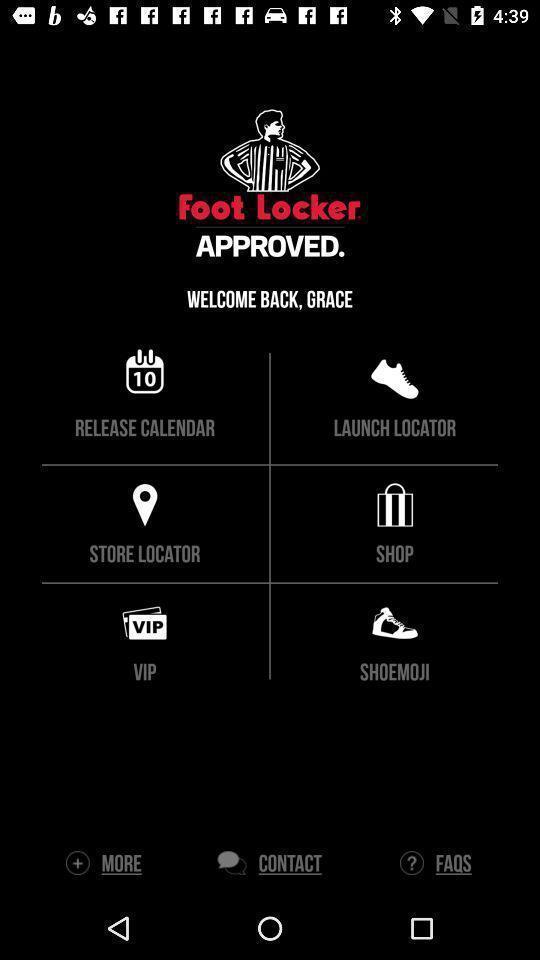Give me a narrative description of this picture. Welcome page to the application with options. 